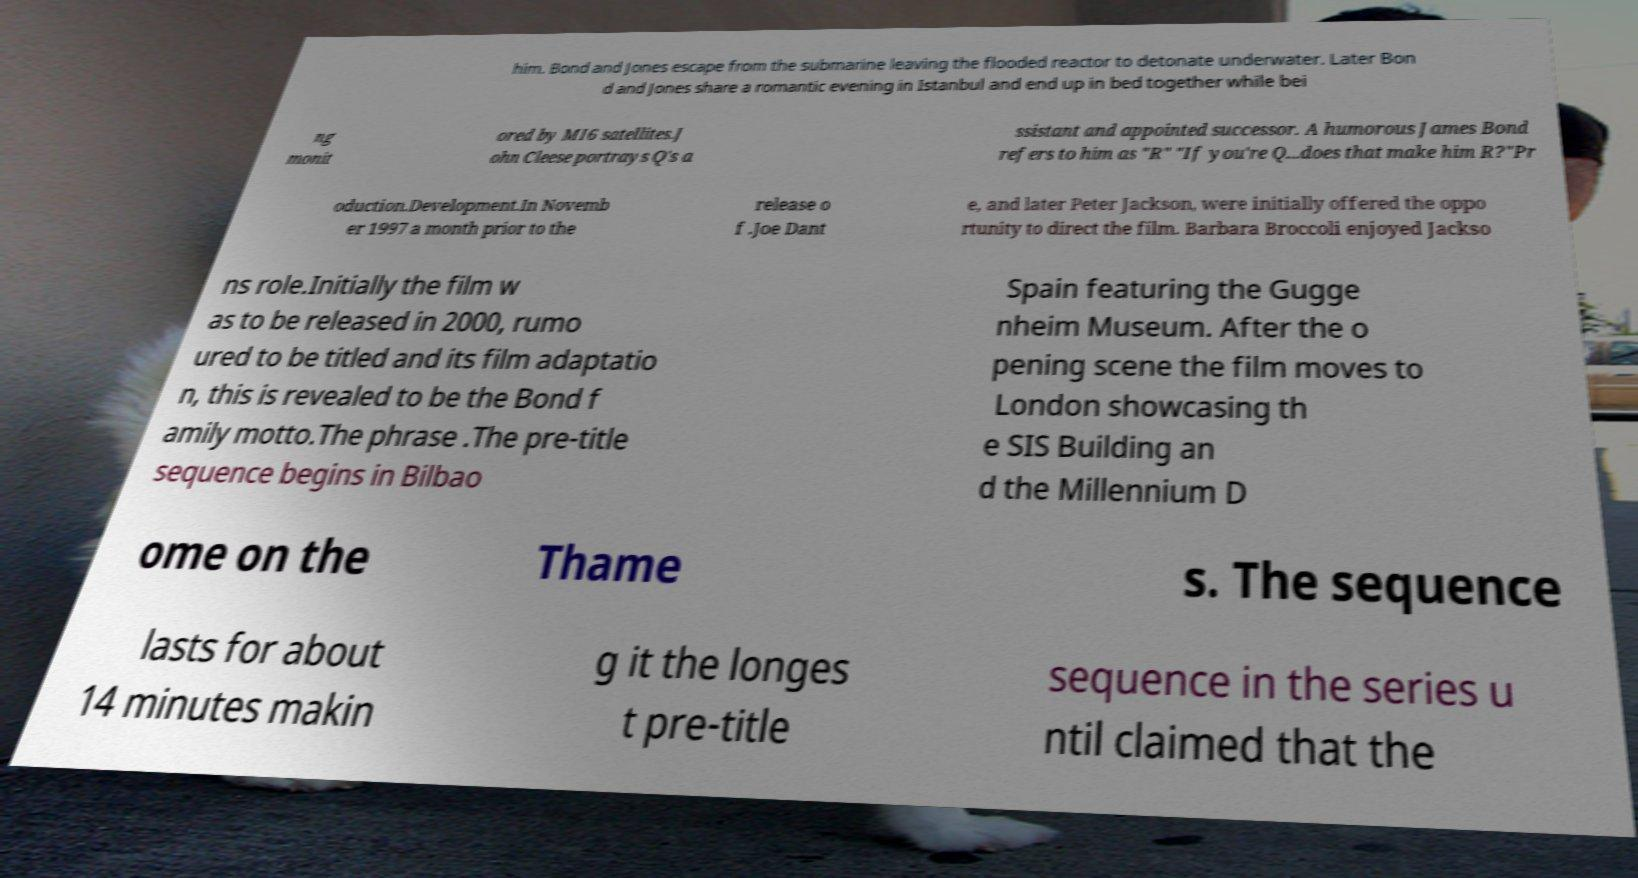What messages or text are displayed in this image? I need them in a readable, typed format. him. Bond and Jones escape from the submarine leaving the flooded reactor to detonate underwater. Later Bon d and Jones share a romantic evening in Istanbul and end up in bed together while bei ng monit ored by MI6 satellites.J ohn Cleese portrays Q's a ssistant and appointed successor. A humorous James Bond refers to him as "R" "If you're Q...does that make him R?"Pr oduction.Development.In Novemb er 1997 a month prior to the release o f .Joe Dant e, and later Peter Jackson, were initially offered the oppo rtunity to direct the film. Barbara Broccoli enjoyed Jackso ns role.Initially the film w as to be released in 2000, rumo ured to be titled and its film adaptatio n, this is revealed to be the Bond f amily motto.The phrase .The pre-title sequence begins in Bilbao Spain featuring the Gugge nheim Museum. After the o pening scene the film moves to London showcasing th e SIS Building an d the Millennium D ome on the Thame s. The sequence lasts for about 14 minutes makin g it the longes t pre-title sequence in the series u ntil claimed that the 